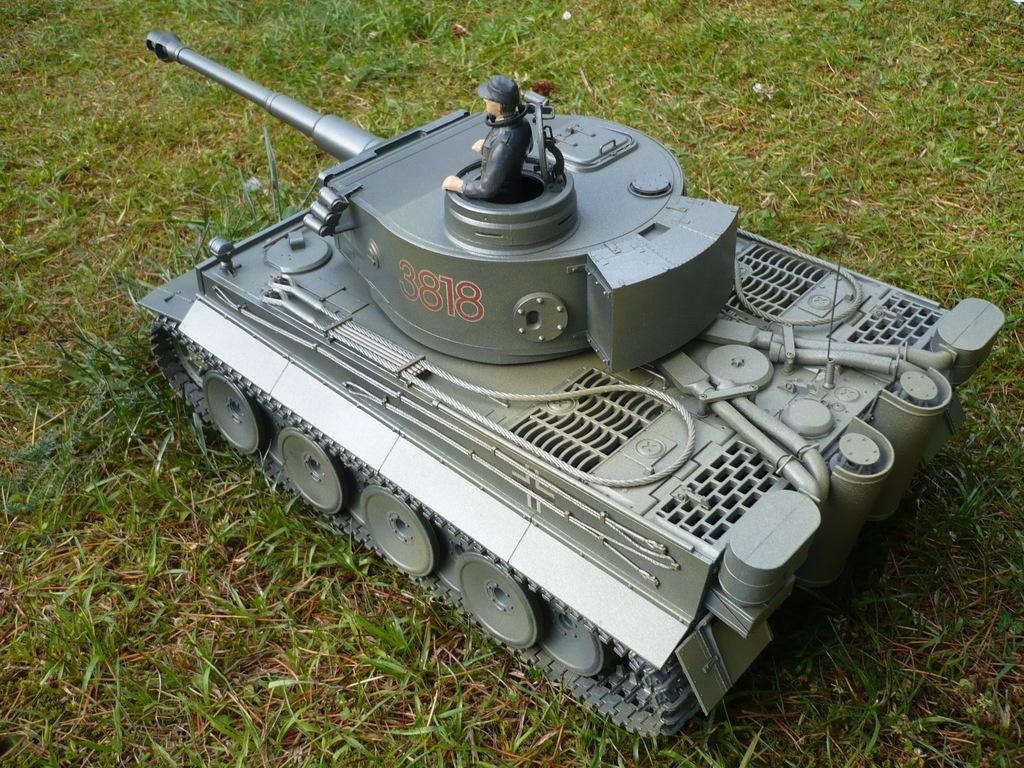What object can be seen in the image? There is a toy in the image. Where is the toy located? The toy is on the grass. What is the name of the downtown rail station featured in the image? There is no downtown rail station present in the image; it only features a toy on the grass. 